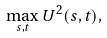<formula> <loc_0><loc_0><loc_500><loc_500>\max _ { s , t } U ^ { 2 } ( s , t ) ,</formula> 